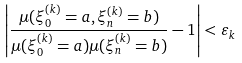<formula> <loc_0><loc_0><loc_500><loc_500>\left | \frac { \mu ( \xi _ { 0 } ^ { ( k ) } = a , \xi _ { n } ^ { ( k ) } = b ) } { \mu ( \xi _ { 0 } ^ { ( k ) } = a ) \mu ( \xi _ { n } ^ { ( k ) } = b ) } - 1 \right | < \varepsilon _ { k }</formula> 